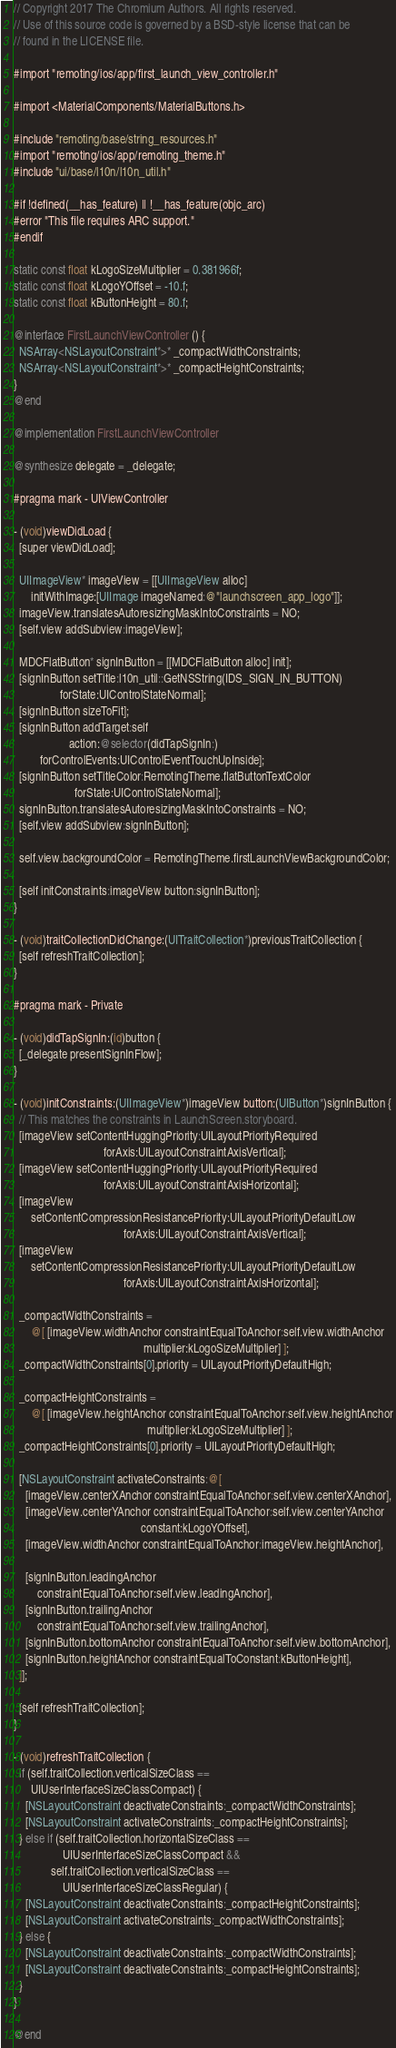Convert code to text. <code><loc_0><loc_0><loc_500><loc_500><_ObjectiveC_>// Copyright 2017 The Chromium Authors. All rights reserved.
// Use of this source code is governed by a BSD-style license that can be
// found in the LICENSE file.

#import "remoting/ios/app/first_launch_view_controller.h"

#import <MaterialComponents/MaterialButtons.h>

#include "remoting/base/string_resources.h"
#import "remoting/ios/app/remoting_theme.h"
#include "ui/base/l10n/l10n_util.h"

#if !defined(__has_feature) || !__has_feature(objc_arc)
#error "This file requires ARC support."
#endif

static const float kLogoSizeMultiplier = 0.381966f;
static const float kLogoYOffset = -10.f;
static const float kButtonHeight = 80.f;

@interface FirstLaunchViewController () {
  NSArray<NSLayoutConstraint*>* _compactWidthConstraints;
  NSArray<NSLayoutConstraint*>* _compactHeightConstraints;
}
@end

@implementation FirstLaunchViewController

@synthesize delegate = _delegate;

#pragma mark - UIViewController

- (void)viewDidLoad {
  [super viewDidLoad];

  UIImageView* imageView = [[UIImageView alloc]
      initWithImage:[UIImage imageNamed:@"launchscreen_app_logo"]];
  imageView.translatesAutoresizingMaskIntoConstraints = NO;
  [self.view addSubview:imageView];

  MDCFlatButton* signInButton = [[MDCFlatButton alloc] init];
  [signInButton setTitle:l10n_util::GetNSString(IDS_SIGN_IN_BUTTON)
                forState:UIControlStateNormal];
  [signInButton sizeToFit];
  [signInButton addTarget:self
                   action:@selector(didTapSignIn:)
         forControlEvents:UIControlEventTouchUpInside];
  [signInButton setTitleColor:RemotingTheme.flatButtonTextColor
                     forState:UIControlStateNormal];
  signInButton.translatesAutoresizingMaskIntoConstraints = NO;
  [self.view addSubview:signInButton];

  self.view.backgroundColor = RemotingTheme.firstLaunchViewBackgroundColor;

  [self initConstraints:imageView button:signInButton];
}

- (void)traitCollectionDidChange:(UITraitCollection*)previousTraitCollection {
  [self refreshTraitCollection];
}

#pragma mark - Private

- (void)didTapSignIn:(id)button {
  [_delegate presentSignInFlow];
}

- (void)initConstraints:(UIImageView*)imageView button:(UIButton*)signInButton {
  // This matches the constraints in LaunchScreen.storyboard.
  [imageView setContentHuggingPriority:UILayoutPriorityRequired
                               forAxis:UILayoutConstraintAxisVertical];
  [imageView setContentHuggingPriority:UILayoutPriorityRequired
                               forAxis:UILayoutConstraintAxisHorizontal];
  [imageView
      setContentCompressionResistancePriority:UILayoutPriorityDefaultLow
                                      forAxis:UILayoutConstraintAxisVertical];
  [imageView
      setContentCompressionResistancePriority:UILayoutPriorityDefaultLow
                                      forAxis:UILayoutConstraintAxisHorizontal];

  _compactWidthConstraints =
      @[ [imageView.widthAnchor constraintEqualToAnchor:self.view.widthAnchor
                                             multiplier:kLogoSizeMultiplier] ];
  _compactWidthConstraints[0].priority = UILayoutPriorityDefaultHigh;

  _compactHeightConstraints =
      @[ [imageView.heightAnchor constraintEqualToAnchor:self.view.heightAnchor
                                              multiplier:kLogoSizeMultiplier] ];
  _compactHeightConstraints[0].priority = UILayoutPriorityDefaultHigh;

  [NSLayoutConstraint activateConstraints:@[
    [imageView.centerXAnchor constraintEqualToAnchor:self.view.centerXAnchor],
    [imageView.centerYAnchor constraintEqualToAnchor:self.view.centerYAnchor
                                            constant:kLogoYOffset],
    [imageView.widthAnchor constraintEqualToAnchor:imageView.heightAnchor],

    [signInButton.leadingAnchor
        constraintEqualToAnchor:self.view.leadingAnchor],
    [signInButton.trailingAnchor
        constraintEqualToAnchor:self.view.trailingAnchor],
    [signInButton.bottomAnchor constraintEqualToAnchor:self.view.bottomAnchor],
    [signInButton.heightAnchor constraintEqualToConstant:kButtonHeight],
  ]];

  [self refreshTraitCollection];
}

- (void)refreshTraitCollection {
  if (self.traitCollection.verticalSizeClass ==
      UIUserInterfaceSizeClassCompact) {
    [NSLayoutConstraint deactivateConstraints:_compactWidthConstraints];
    [NSLayoutConstraint activateConstraints:_compactHeightConstraints];
  } else if (self.traitCollection.horizontalSizeClass ==
                 UIUserInterfaceSizeClassCompact &&
             self.traitCollection.verticalSizeClass ==
                 UIUserInterfaceSizeClassRegular) {
    [NSLayoutConstraint deactivateConstraints:_compactHeightConstraints];
    [NSLayoutConstraint activateConstraints:_compactWidthConstraints];
  } else {
    [NSLayoutConstraint deactivateConstraints:_compactWidthConstraints];
    [NSLayoutConstraint deactivateConstraints:_compactHeightConstraints];
  }
}

@end
</code> 